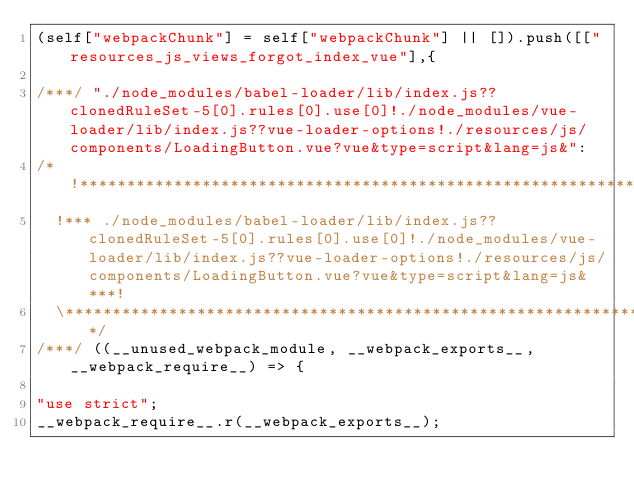<code> <loc_0><loc_0><loc_500><loc_500><_JavaScript_>(self["webpackChunk"] = self["webpackChunk"] || []).push([["resources_js_views_forgot_index_vue"],{

/***/ "./node_modules/babel-loader/lib/index.js??clonedRuleSet-5[0].rules[0].use[0]!./node_modules/vue-loader/lib/index.js??vue-loader-options!./resources/js/components/LoadingButton.vue?vue&type=script&lang=js&":
/*!********************************************************************************************************************************************************************************************************************!*\
  !*** ./node_modules/babel-loader/lib/index.js??clonedRuleSet-5[0].rules[0].use[0]!./node_modules/vue-loader/lib/index.js??vue-loader-options!./resources/js/components/LoadingButton.vue?vue&type=script&lang=js& ***!
  \********************************************************************************************************************************************************************************************************************/
/***/ ((__unused_webpack_module, __webpack_exports__, __webpack_require__) => {

"use strict";
__webpack_require__.r(__webpack_exports__);</code> 